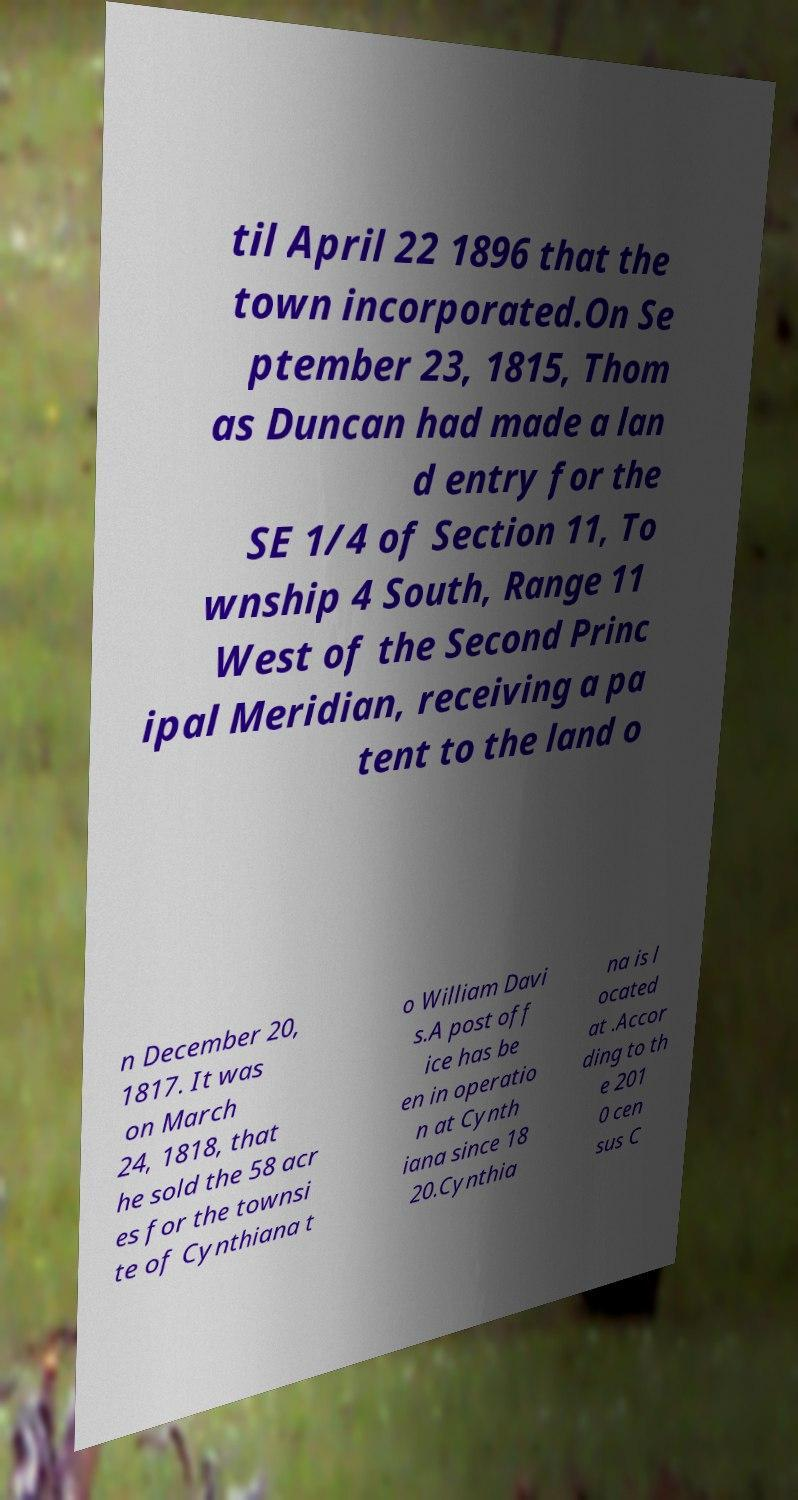For documentation purposes, I need the text within this image transcribed. Could you provide that? til April 22 1896 that the town incorporated.On Se ptember 23, 1815, Thom as Duncan had made a lan d entry for the SE 1/4 of Section 11, To wnship 4 South, Range 11 West of the Second Princ ipal Meridian, receiving a pa tent to the land o n December 20, 1817. It was on March 24, 1818, that he sold the 58 acr es for the townsi te of Cynthiana t o William Davi s.A post off ice has be en in operatio n at Cynth iana since 18 20.Cynthia na is l ocated at .Accor ding to th e 201 0 cen sus C 